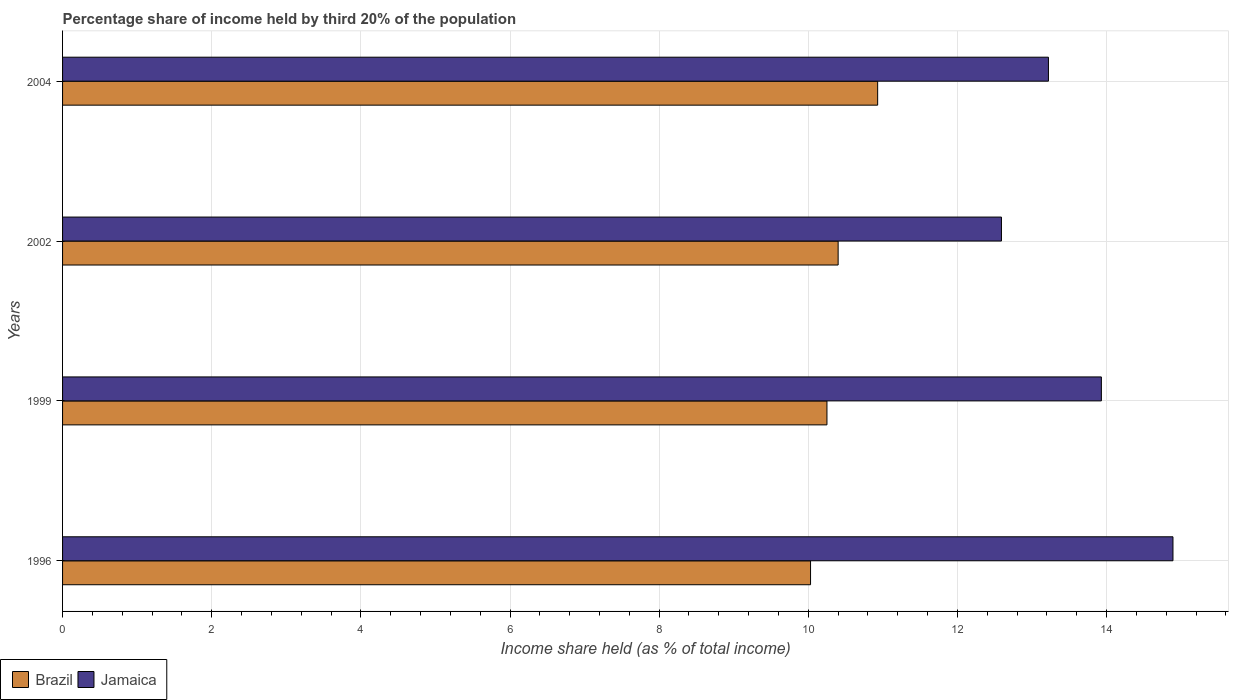How many groups of bars are there?
Give a very brief answer. 4. Are the number of bars per tick equal to the number of legend labels?
Make the answer very short. Yes. How many bars are there on the 3rd tick from the top?
Offer a terse response. 2. What is the share of income held by third 20% of the population in Jamaica in 2004?
Offer a very short reply. 13.22. Across all years, what is the maximum share of income held by third 20% of the population in Jamaica?
Provide a short and direct response. 14.89. Across all years, what is the minimum share of income held by third 20% of the population in Brazil?
Ensure brevity in your answer.  10.03. In which year was the share of income held by third 20% of the population in Brazil minimum?
Provide a short and direct response. 1996. What is the total share of income held by third 20% of the population in Jamaica in the graph?
Provide a short and direct response. 54.63. What is the difference between the share of income held by third 20% of the population in Jamaica in 2002 and that in 2004?
Make the answer very short. -0.63. What is the difference between the share of income held by third 20% of the population in Brazil in 2004 and the share of income held by third 20% of the population in Jamaica in 2002?
Your answer should be very brief. -1.66. What is the average share of income held by third 20% of the population in Jamaica per year?
Your response must be concise. 13.66. In the year 2002, what is the difference between the share of income held by third 20% of the population in Brazil and share of income held by third 20% of the population in Jamaica?
Keep it short and to the point. -2.19. In how many years, is the share of income held by third 20% of the population in Brazil greater than 13.2 %?
Provide a short and direct response. 0. What is the ratio of the share of income held by third 20% of the population in Jamaica in 1999 to that in 2002?
Keep it short and to the point. 1.11. Is the difference between the share of income held by third 20% of the population in Brazil in 1996 and 1999 greater than the difference between the share of income held by third 20% of the population in Jamaica in 1996 and 1999?
Offer a terse response. No. What is the difference between the highest and the second highest share of income held by third 20% of the population in Jamaica?
Your response must be concise. 0.96. What is the difference between the highest and the lowest share of income held by third 20% of the population in Jamaica?
Offer a terse response. 2.3. Is the sum of the share of income held by third 20% of the population in Jamaica in 1996 and 2004 greater than the maximum share of income held by third 20% of the population in Brazil across all years?
Offer a terse response. Yes. What does the 1st bar from the top in 2004 represents?
Give a very brief answer. Jamaica. What does the 2nd bar from the bottom in 1999 represents?
Offer a very short reply. Jamaica. Are all the bars in the graph horizontal?
Offer a very short reply. Yes. Does the graph contain grids?
Your answer should be very brief. Yes. How many legend labels are there?
Give a very brief answer. 2. What is the title of the graph?
Make the answer very short. Percentage share of income held by third 20% of the population. What is the label or title of the X-axis?
Offer a very short reply. Income share held (as % of total income). What is the Income share held (as % of total income) of Brazil in 1996?
Make the answer very short. 10.03. What is the Income share held (as % of total income) in Jamaica in 1996?
Provide a short and direct response. 14.89. What is the Income share held (as % of total income) of Brazil in 1999?
Provide a succinct answer. 10.25. What is the Income share held (as % of total income) in Jamaica in 1999?
Your answer should be very brief. 13.93. What is the Income share held (as % of total income) in Brazil in 2002?
Your response must be concise. 10.4. What is the Income share held (as % of total income) in Jamaica in 2002?
Ensure brevity in your answer.  12.59. What is the Income share held (as % of total income) of Brazil in 2004?
Provide a short and direct response. 10.93. What is the Income share held (as % of total income) of Jamaica in 2004?
Make the answer very short. 13.22. Across all years, what is the maximum Income share held (as % of total income) in Brazil?
Your answer should be very brief. 10.93. Across all years, what is the maximum Income share held (as % of total income) in Jamaica?
Offer a terse response. 14.89. Across all years, what is the minimum Income share held (as % of total income) of Brazil?
Give a very brief answer. 10.03. Across all years, what is the minimum Income share held (as % of total income) of Jamaica?
Give a very brief answer. 12.59. What is the total Income share held (as % of total income) of Brazil in the graph?
Keep it short and to the point. 41.61. What is the total Income share held (as % of total income) in Jamaica in the graph?
Offer a very short reply. 54.63. What is the difference between the Income share held (as % of total income) of Brazil in 1996 and that in 1999?
Provide a short and direct response. -0.22. What is the difference between the Income share held (as % of total income) of Jamaica in 1996 and that in 1999?
Offer a very short reply. 0.96. What is the difference between the Income share held (as % of total income) of Brazil in 1996 and that in 2002?
Keep it short and to the point. -0.37. What is the difference between the Income share held (as % of total income) in Jamaica in 1996 and that in 2004?
Your response must be concise. 1.67. What is the difference between the Income share held (as % of total income) of Brazil in 1999 and that in 2002?
Your response must be concise. -0.15. What is the difference between the Income share held (as % of total income) in Jamaica in 1999 and that in 2002?
Ensure brevity in your answer.  1.34. What is the difference between the Income share held (as % of total income) of Brazil in 1999 and that in 2004?
Give a very brief answer. -0.68. What is the difference between the Income share held (as % of total income) in Jamaica in 1999 and that in 2004?
Ensure brevity in your answer.  0.71. What is the difference between the Income share held (as % of total income) in Brazil in 2002 and that in 2004?
Your answer should be compact. -0.53. What is the difference between the Income share held (as % of total income) in Jamaica in 2002 and that in 2004?
Ensure brevity in your answer.  -0.63. What is the difference between the Income share held (as % of total income) in Brazil in 1996 and the Income share held (as % of total income) in Jamaica in 1999?
Provide a short and direct response. -3.9. What is the difference between the Income share held (as % of total income) of Brazil in 1996 and the Income share held (as % of total income) of Jamaica in 2002?
Offer a terse response. -2.56. What is the difference between the Income share held (as % of total income) of Brazil in 1996 and the Income share held (as % of total income) of Jamaica in 2004?
Provide a short and direct response. -3.19. What is the difference between the Income share held (as % of total income) of Brazil in 1999 and the Income share held (as % of total income) of Jamaica in 2002?
Make the answer very short. -2.34. What is the difference between the Income share held (as % of total income) in Brazil in 1999 and the Income share held (as % of total income) in Jamaica in 2004?
Your answer should be very brief. -2.97. What is the difference between the Income share held (as % of total income) in Brazil in 2002 and the Income share held (as % of total income) in Jamaica in 2004?
Offer a terse response. -2.82. What is the average Income share held (as % of total income) in Brazil per year?
Ensure brevity in your answer.  10.4. What is the average Income share held (as % of total income) in Jamaica per year?
Keep it short and to the point. 13.66. In the year 1996, what is the difference between the Income share held (as % of total income) of Brazil and Income share held (as % of total income) of Jamaica?
Your answer should be compact. -4.86. In the year 1999, what is the difference between the Income share held (as % of total income) of Brazil and Income share held (as % of total income) of Jamaica?
Keep it short and to the point. -3.68. In the year 2002, what is the difference between the Income share held (as % of total income) in Brazil and Income share held (as % of total income) in Jamaica?
Ensure brevity in your answer.  -2.19. In the year 2004, what is the difference between the Income share held (as % of total income) in Brazil and Income share held (as % of total income) in Jamaica?
Provide a succinct answer. -2.29. What is the ratio of the Income share held (as % of total income) of Brazil in 1996 to that in 1999?
Your answer should be compact. 0.98. What is the ratio of the Income share held (as % of total income) in Jamaica in 1996 to that in 1999?
Your answer should be compact. 1.07. What is the ratio of the Income share held (as % of total income) in Brazil in 1996 to that in 2002?
Offer a terse response. 0.96. What is the ratio of the Income share held (as % of total income) in Jamaica in 1996 to that in 2002?
Your response must be concise. 1.18. What is the ratio of the Income share held (as % of total income) in Brazil in 1996 to that in 2004?
Make the answer very short. 0.92. What is the ratio of the Income share held (as % of total income) of Jamaica in 1996 to that in 2004?
Your answer should be very brief. 1.13. What is the ratio of the Income share held (as % of total income) in Brazil in 1999 to that in 2002?
Your response must be concise. 0.99. What is the ratio of the Income share held (as % of total income) in Jamaica in 1999 to that in 2002?
Provide a short and direct response. 1.11. What is the ratio of the Income share held (as % of total income) of Brazil in 1999 to that in 2004?
Make the answer very short. 0.94. What is the ratio of the Income share held (as % of total income) in Jamaica in 1999 to that in 2004?
Offer a terse response. 1.05. What is the ratio of the Income share held (as % of total income) of Brazil in 2002 to that in 2004?
Give a very brief answer. 0.95. What is the ratio of the Income share held (as % of total income) in Jamaica in 2002 to that in 2004?
Make the answer very short. 0.95. What is the difference between the highest and the second highest Income share held (as % of total income) of Brazil?
Give a very brief answer. 0.53. What is the difference between the highest and the second highest Income share held (as % of total income) in Jamaica?
Make the answer very short. 0.96. What is the difference between the highest and the lowest Income share held (as % of total income) of Brazil?
Your answer should be very brief. 0.9. What is the difference between the highest and the lowest Income share held (as % of total income) in Jamaica?
Make the answer very short. 2.3. 